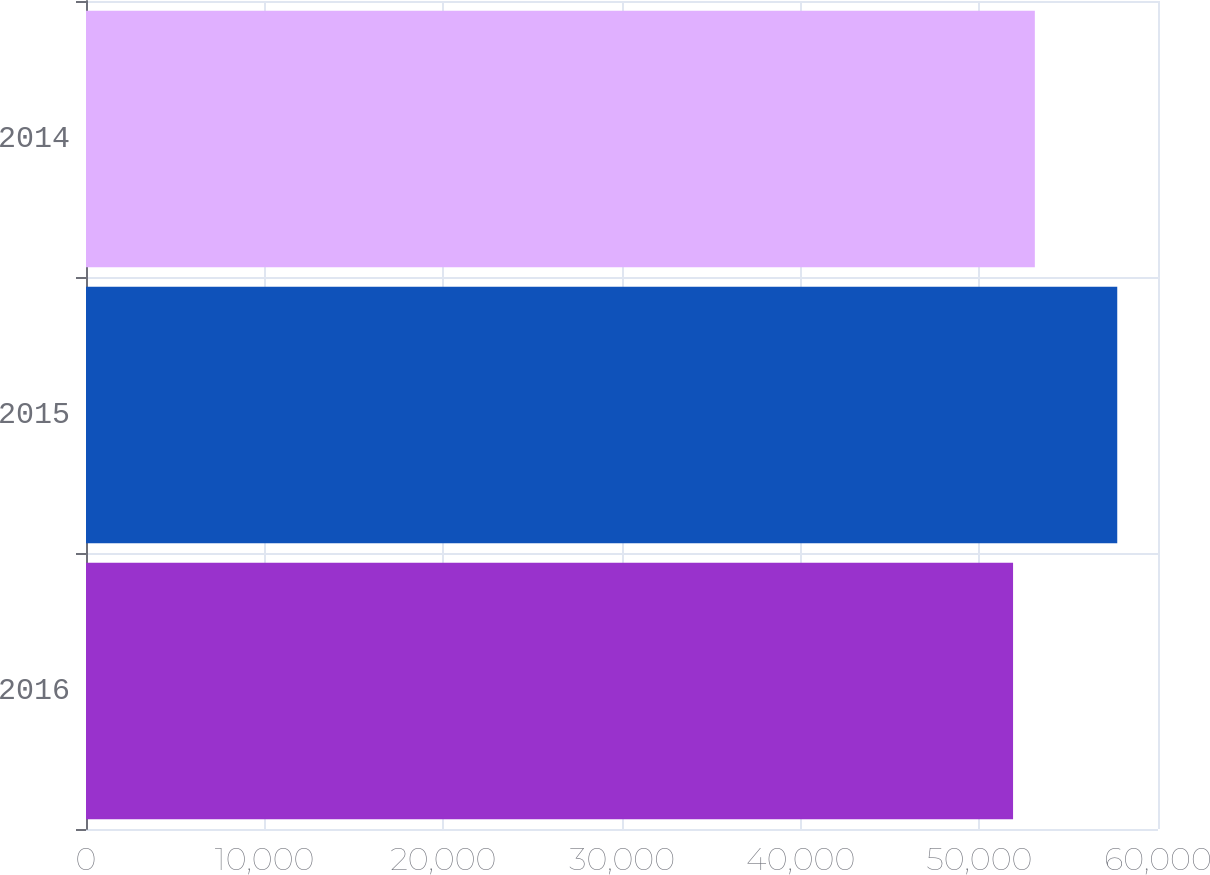Convert chart to OTSL. <chart><loc_0><loc_0><loc_500><loc_500><bar_chart><fcel>2016<fcel>2015<fcel>2014<nl><fcel>51888<fcel>57719<fcel>53107<nl></chart> 